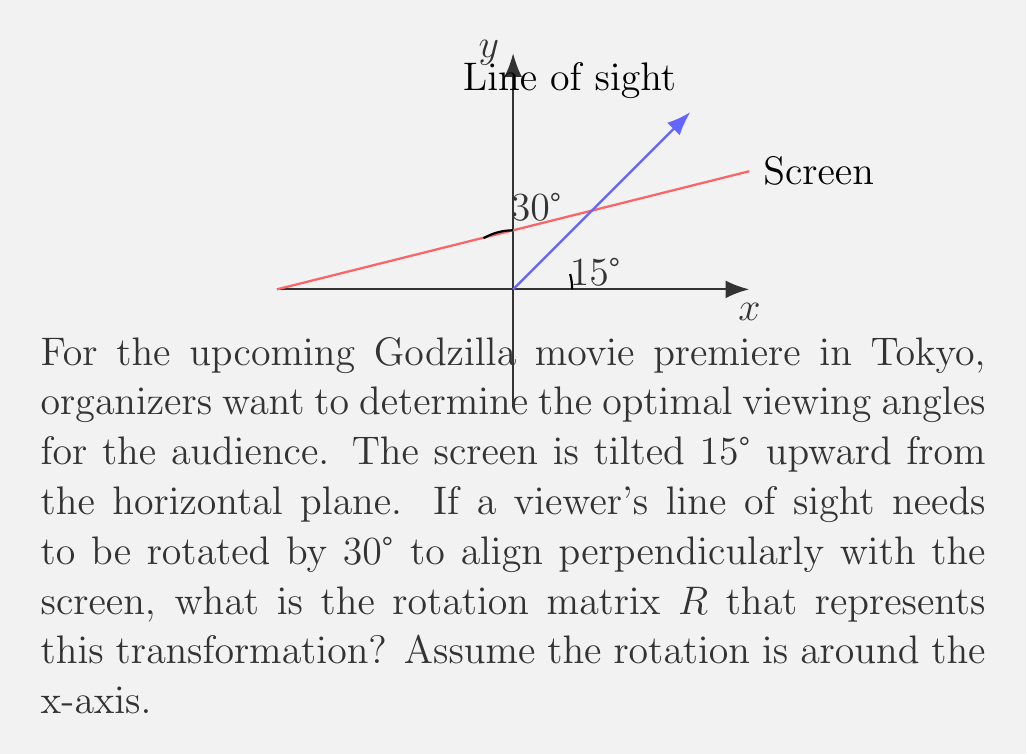Provide a solution to this math problem. Let's approach this step-by-step:

1) The rotation matrix for a rotation around the x-axis by an angle $\theta$ is given by:

   $$R_x(\theta) = \begin{pmatrix}
   1 & 0 & 0 \\
   0 & \cos\theta & -\sin\theta \\
   0 & \sin\theta & \cos\theta
   \end{pmatrix}$$

2) In this case, we need to rotate the line of sight by 30° to align it perpendicularly with the screen. However, the screen is already tilted 15° upward.

3) Therefore, the total rotation angle $\theta$ is:
   
   $\theta = 30° - 15° = 15°$

4) We need to find $\cos 15°$ and $\sin 15°$. We can use the following exact values:

   $\cos 15° = \frac{\sqrt{6} + \sqrt{2}}{4}$
   
   $\sin 15° = \frac{\sqrt{6} - \sqrt{2}}{4}$

5) Substituting these values into the rotation matrix:

   $$R = \begin{pmatrix}
   1 & 0 & 0 \\
   0 & \frac{\sqrt{6} + \sqrt{2}}{4} & -\frac{\sqrt{6} - \sqrt{2}}{4} \\
   0 & \frac{\sqrt{6} - \sqrt{2}}{4} & \frac{\sqrt{6} + \sqrt{2}}{4}
   \end{pmatrix}$$

This matrix $R$ represents the optimal rotation for viewing the Godzilla movie premiere screen.
Answer: $$R = \begin{pmatrix}
1 & 0 & 0 \\
0 & \frac{\sqrt{6} + \sqrt{2}}{4} & -\frac{\sqrt{6} - \sqrt{2}}{4} \\
0 & \frac{\sqrt{6} - \sqrt{2}}{4} & \frac{\sqrt{6} + \sqrt{2}}{4}
\end{pmatrix}$$ 